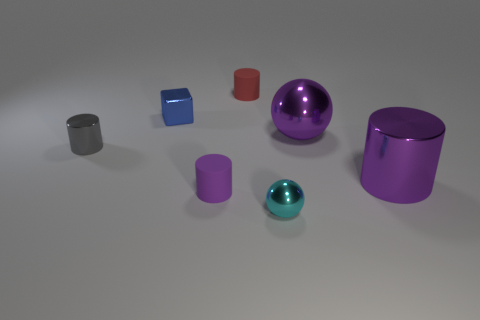Add 3 large blue shiny spheres. How many objects exist? 10 Subtract all small red matte cylinders. How many cylinders are left? 3 Subtract all gray blocks. How many purple cylinders are left? 2 Subtract all red cylinders. How many cylinders are left? 3 Subtract 2 cylinders. How many cylinders are left? 2 Subtract all cubes. How many objects are left? 6 Subtract all brown cylinders. Subtract all cyan spheres. How many cylinders are left? 4 Add 7 tiny cyan metallic objects. How many tiny cyan metallic objects exist? 8 Subtract 1 blue blocks. How many objects are left? 6 Subtract all small red cylinders. Subtract all tiny metal objects. How many objects are left? 3 